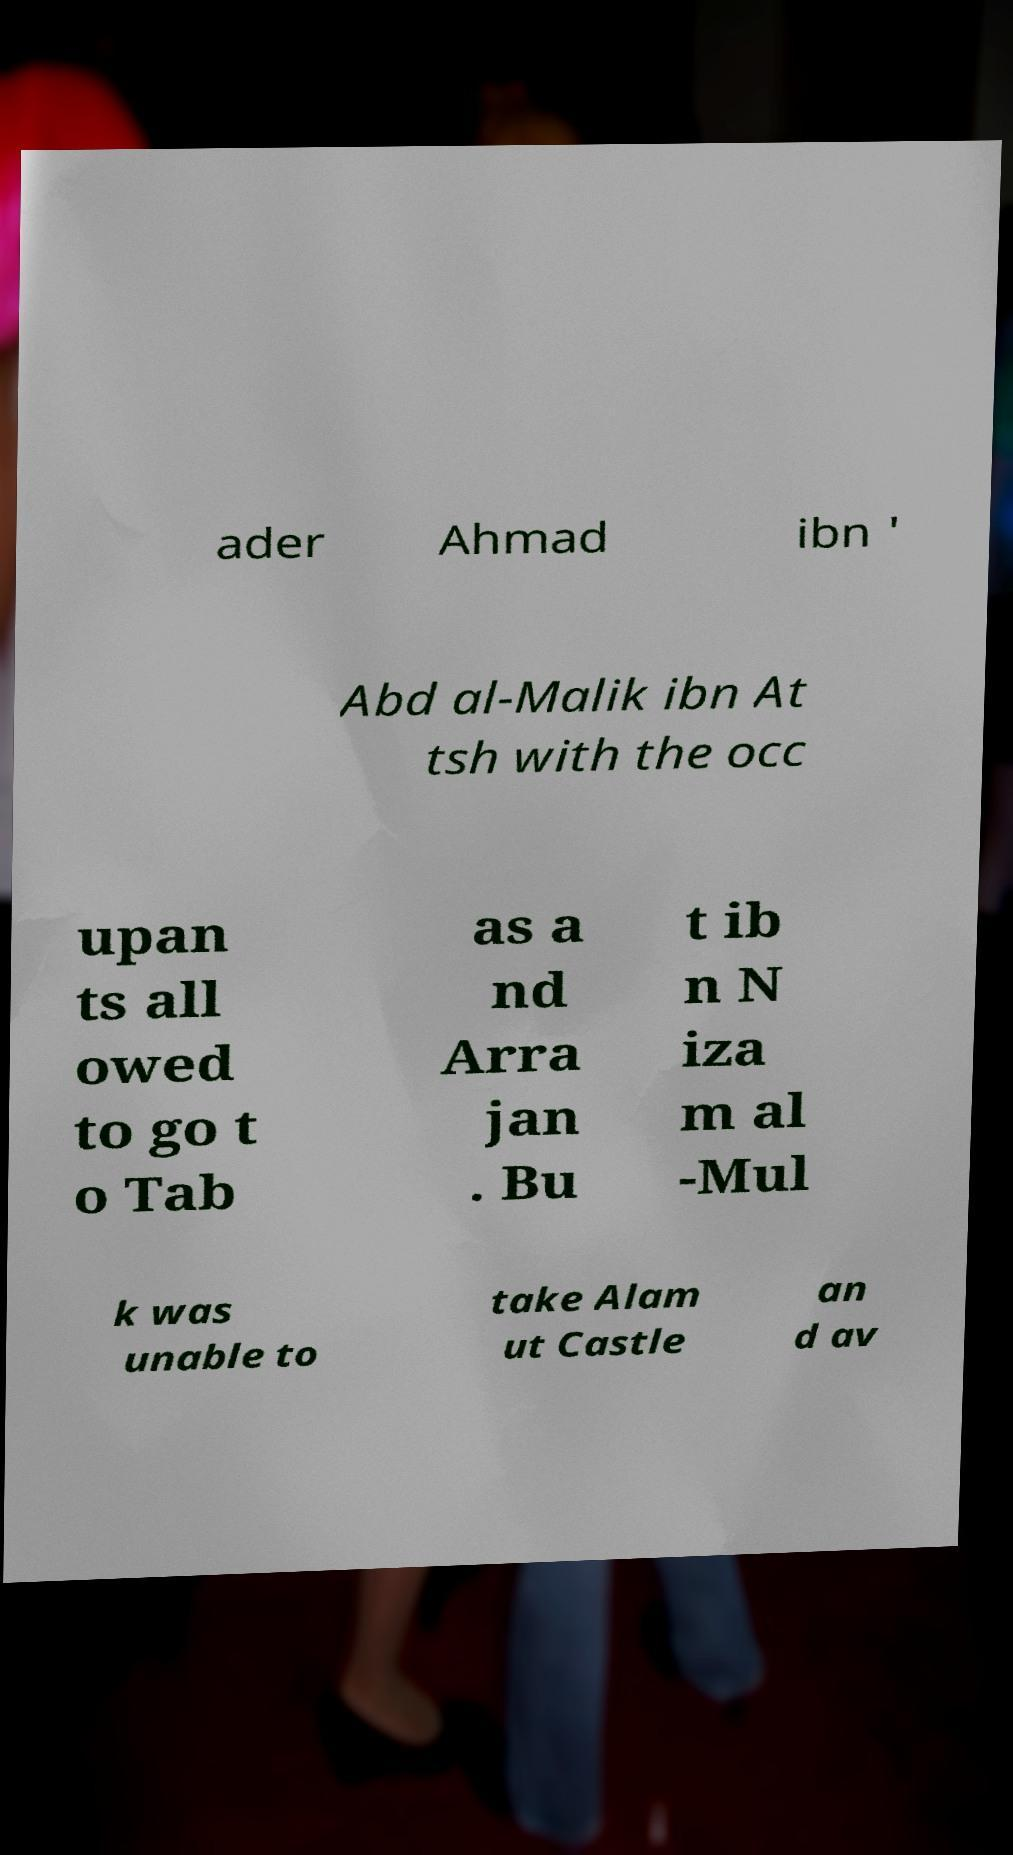Could you assist in decoding the text presented in this image and type it out clearly? ader Ahmad ibn ' Abd al-Malik ibn At tsh with the occ upan ts all owed to go t o Tab as a nd Arra jan . Bu t ib n N iza m al -Mul k was unable to take Alam ut Castle an d av 